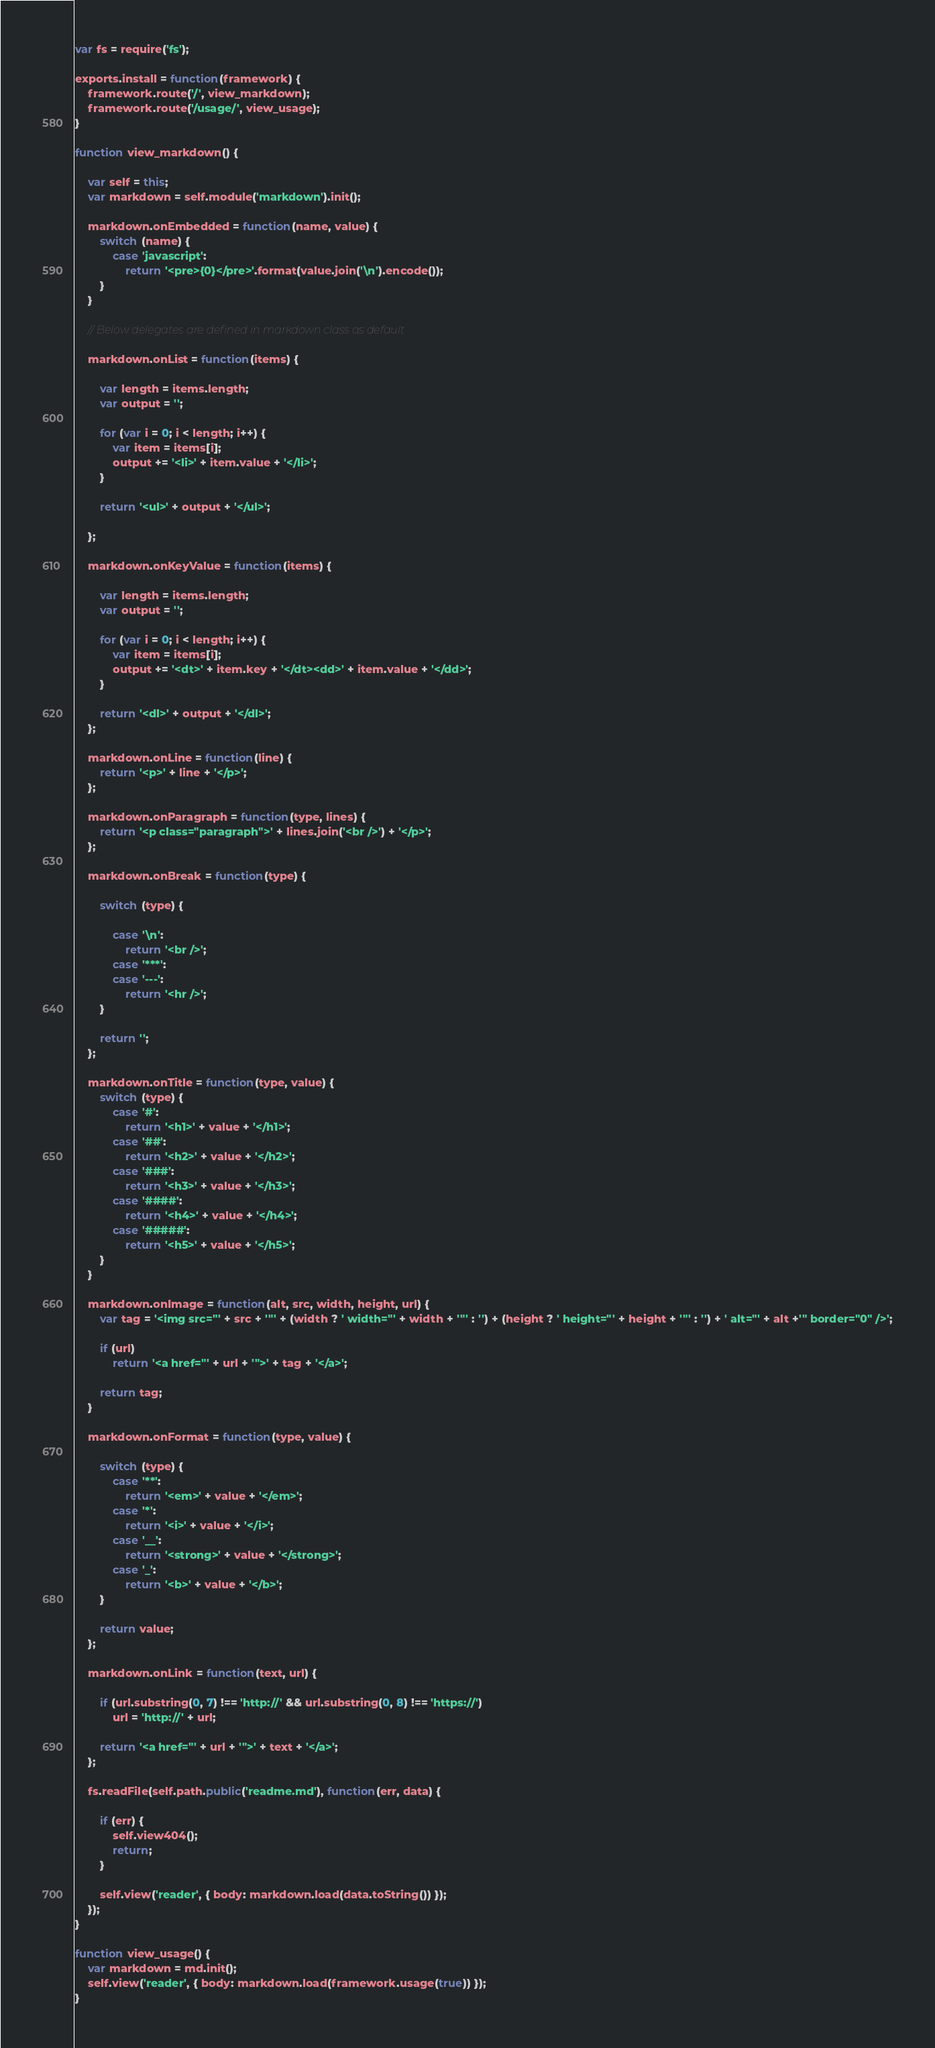Convert code to text. <code><loc_0><loc_0><loc_500><loc_500><_JavaScript_>var fs = require('fs');

exports.install = function(framework) {
	framework.route('/', view_markdown);
    framework.route('/usage/', view_usage);
}

function view_markdown() {

	var self = this;
	var markdown = self.module('markdown').init();

	markdown.onEmbedded = function(name, value) {
		switch (name) {
			case 'javascript':
				return '<pre>{0}</pre>'.format(value.join('\n').encode());
		}
	}

	// Below delegates are defined in markdown class as default
	
	markdown.onList = function(items) {

        var length = items.length;
        var output = '';

        for (var i = 0; i < length; i++) {
            var item = items[i];
            output += '<li>' + item.value + '</li>';
        }

        return '<ul>' + output + '</ul>';

    };

    markdown.onKeyValue = function(items) {

        var length = items.length;
        var output = '';

        for (var i = 0; i < length; i++) {
            var item = items[i];
            output += '<dt>' + item.key + '</dt><dd>' + item.value + '</dd>';
        }

        return '<dl>' + output + '</dl>';
    };

    markdown.onLine = function(line) {
        return '<p>' + line + '</p>';
    };

    markdown.onParagraph = function(type, lines) {
        return '<p class="paragraph">' + lines.join('<br />') + '</p>';
    };

    markdown.onBreak = function(type) {

    	switch (type) {

    		case '\n':
    			return '<br />';
    		case '***':
    		case '---':
    			return '<hr />';
    	}

    	return '';
    };

	markdown.onTitle = function(type, value) {
		switch (type) {
			case '#':
				return '<h1>' + value + '</h1>';
			case '##':
				return '<h2>' + value + '</h2>';
			case '###':
				return '<h3>' + value + '</h3>';
			case '####':
				return '<h4>' + value + '</h4>';
			case '#####':
				return '<h5>' + value + '</h5>';
		}
	}

	markdown.onImage = function(alt, src, width, height, url) {
        var tag = '<img src="' + src + '"' + (width ? ' width="' + width + '"' : '') + (height ? ' height="' + height + '"' : '') + ' alt="' + alt +'" border="0" />';

        if (url)
            return '<a href="' + url + '">' + tag + '</a>';

        return tag;
	}

	markdown.onFormat = function(type, value) {

        switch (type) {
            case '**':
                return '<em>' + value + '</em>';
            case '*':
                return '<i>' + value + '</i>';
            case '__':
                return '<strong>' + value + '</strong>';
            case '_':
                return '<b>' + value + '</b>';
        }

        return value;
    };

    markdown.onLink = function(text, url) {

        if (url.substring(0, 7) !== 'http://' && url.substring(0, 8) !== 'https://')
            url = 'http://' + url;

        return '<a href="' + url + '">' + text + '</a>';
    };

	fs.readFile(self.path.public('readme.md'), function(err, data) {

		if (err) {
			self.view404();
			return;
		}

		self.view('reader', { body: markdown.load(data.toString()) });
	});
}

function view_usage() {
    var markdown = md.init();
    self.view('reader', { body: markdown.load(framework.usage(true)) });
}</code> 